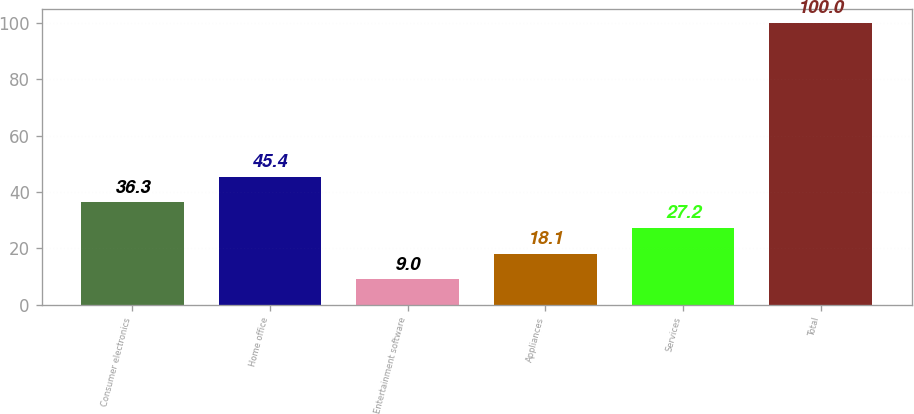<chart> <loc_0><loc_0><loc_500><loc_500><bar_chart><fcel>Consumer electronics<fcel>Home office<fcel>Entertainment software<fcel>Appliances<fcel>Services<fcel>Total<nl><fcel>36.3<fcel>45.4<fcel>9<fcel>18.1<fcel>27.2<fcel>100<nl></chart> 